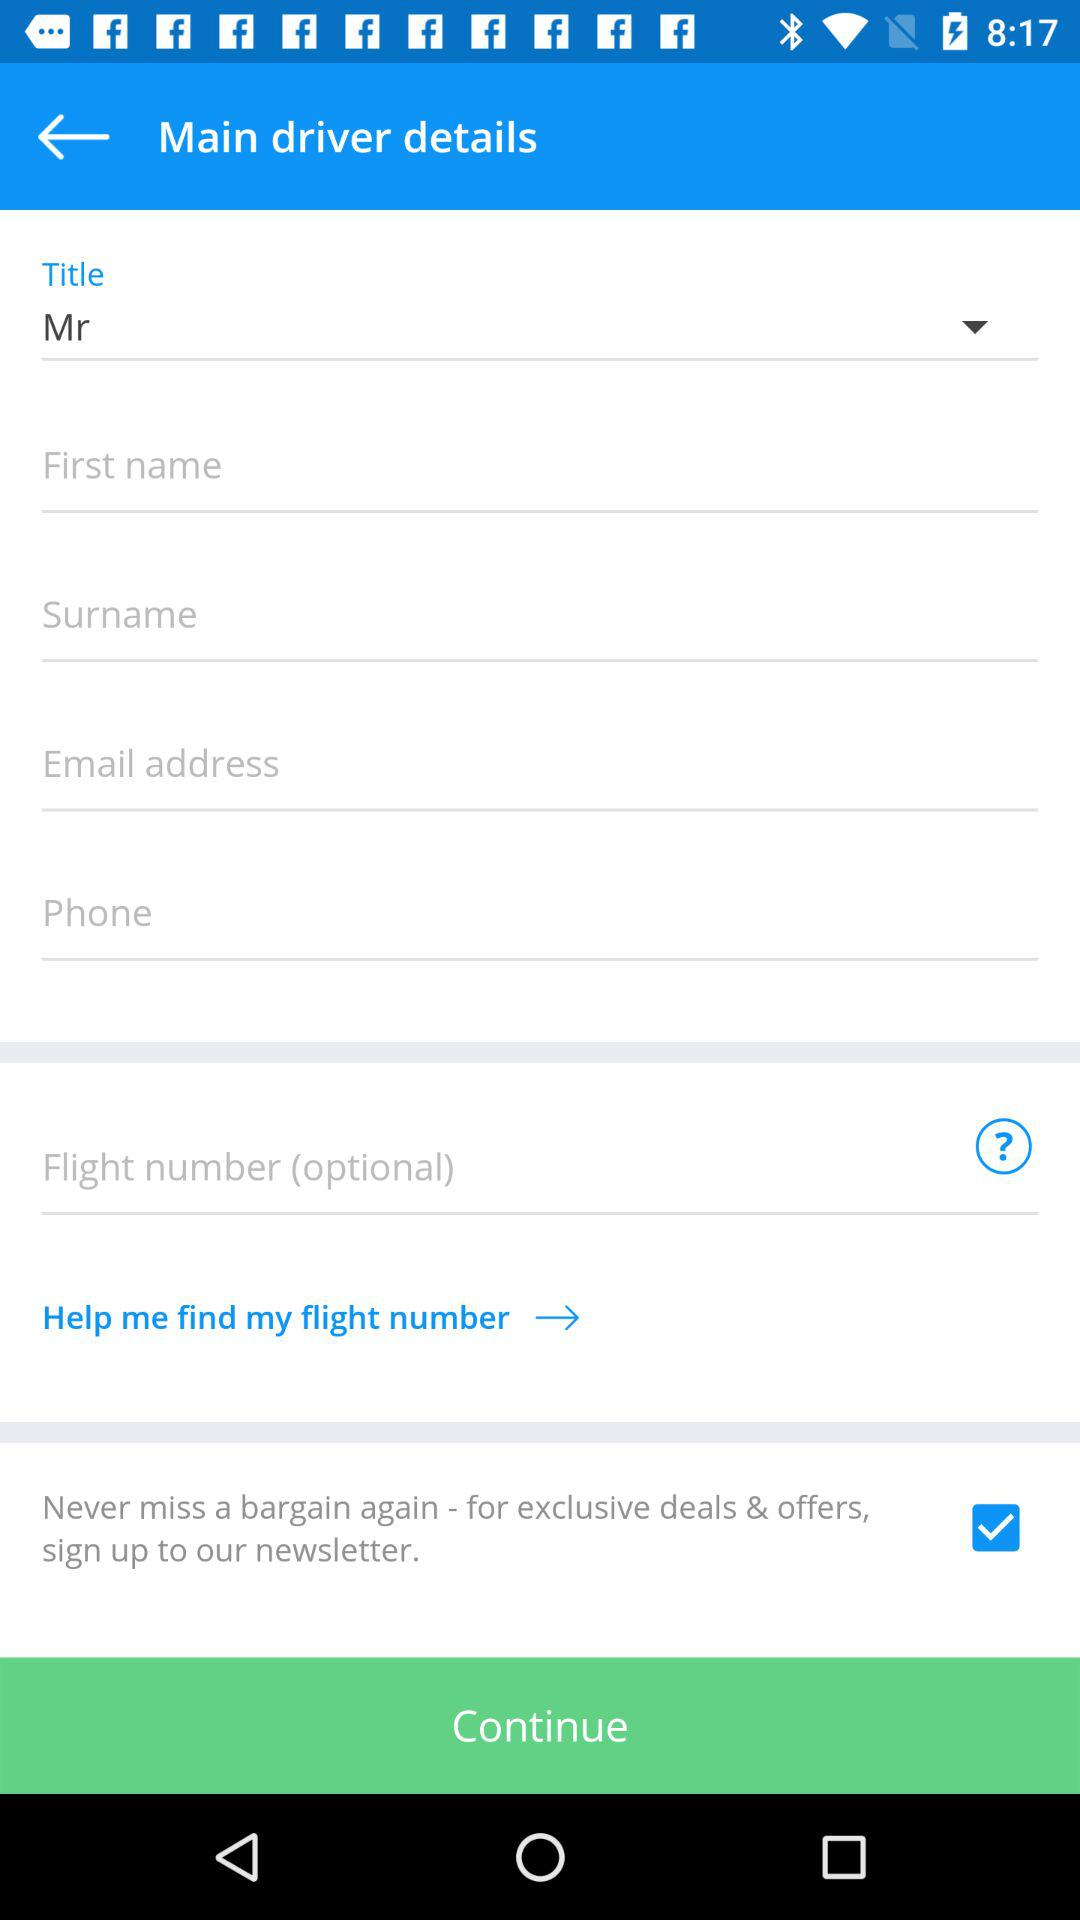How many input fields are there for the main driver's details?
Answer the question using a single word or phrase. 6 